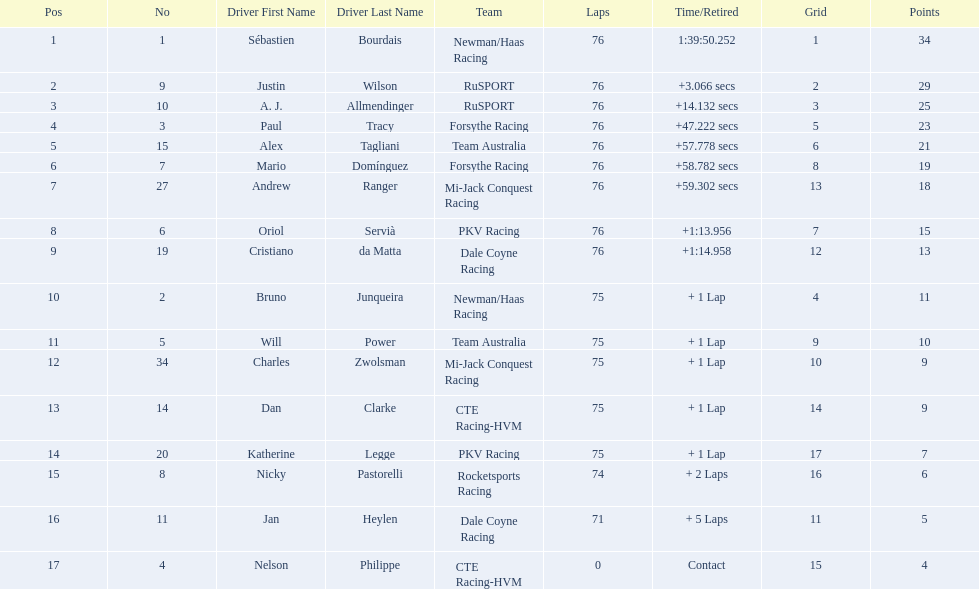Is there a driver named charles zwolsman? Charles Zwolsman. How many points did he acquire? 9. Were there any other entries that got the same number of points? 9. Who did that entry belong to? Dan Clarke. 